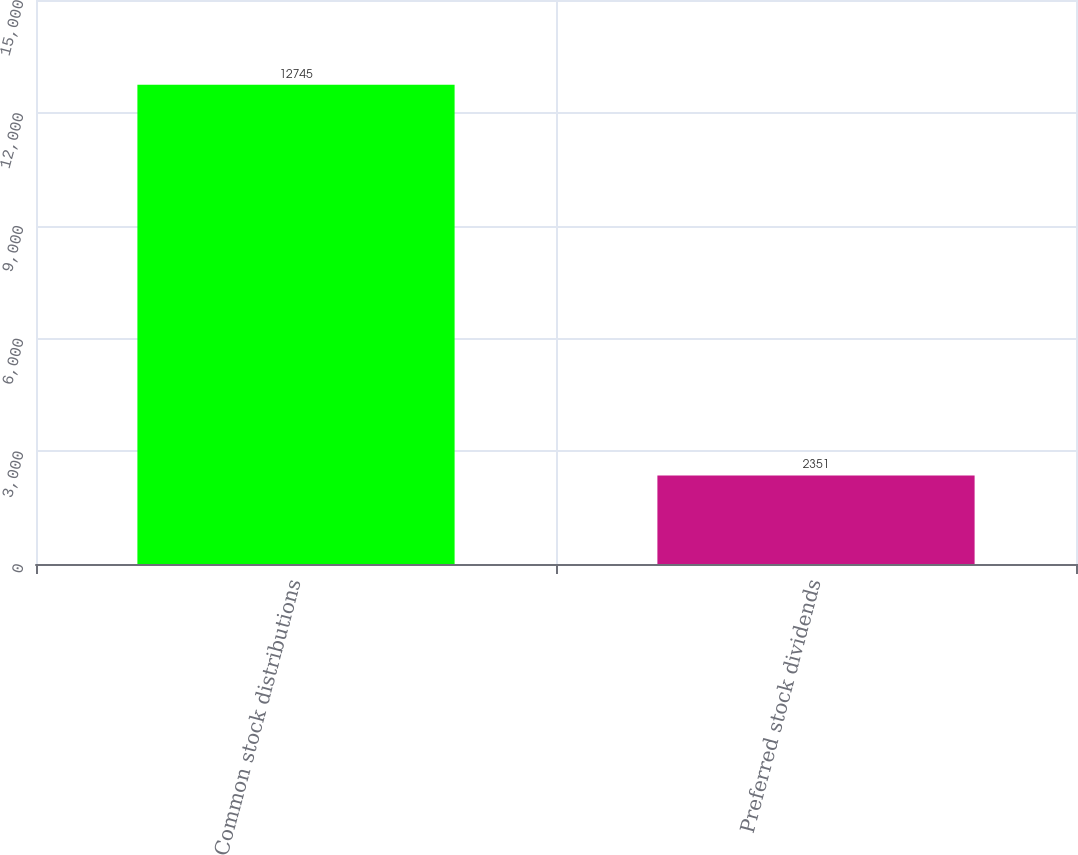Convert chart to OTSL. <chart><loc_0><loc_0><loc_500><loc_500><bar_chart><fcel>Common stock distributions<fcel>Preferred stock dividends<nl><fcel>12745<fcel>2351<nl></chart> 